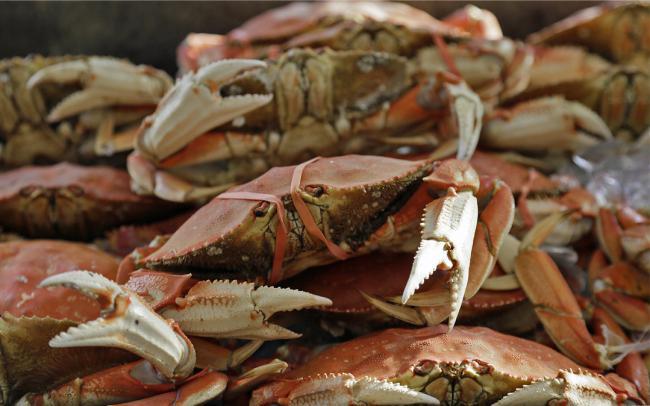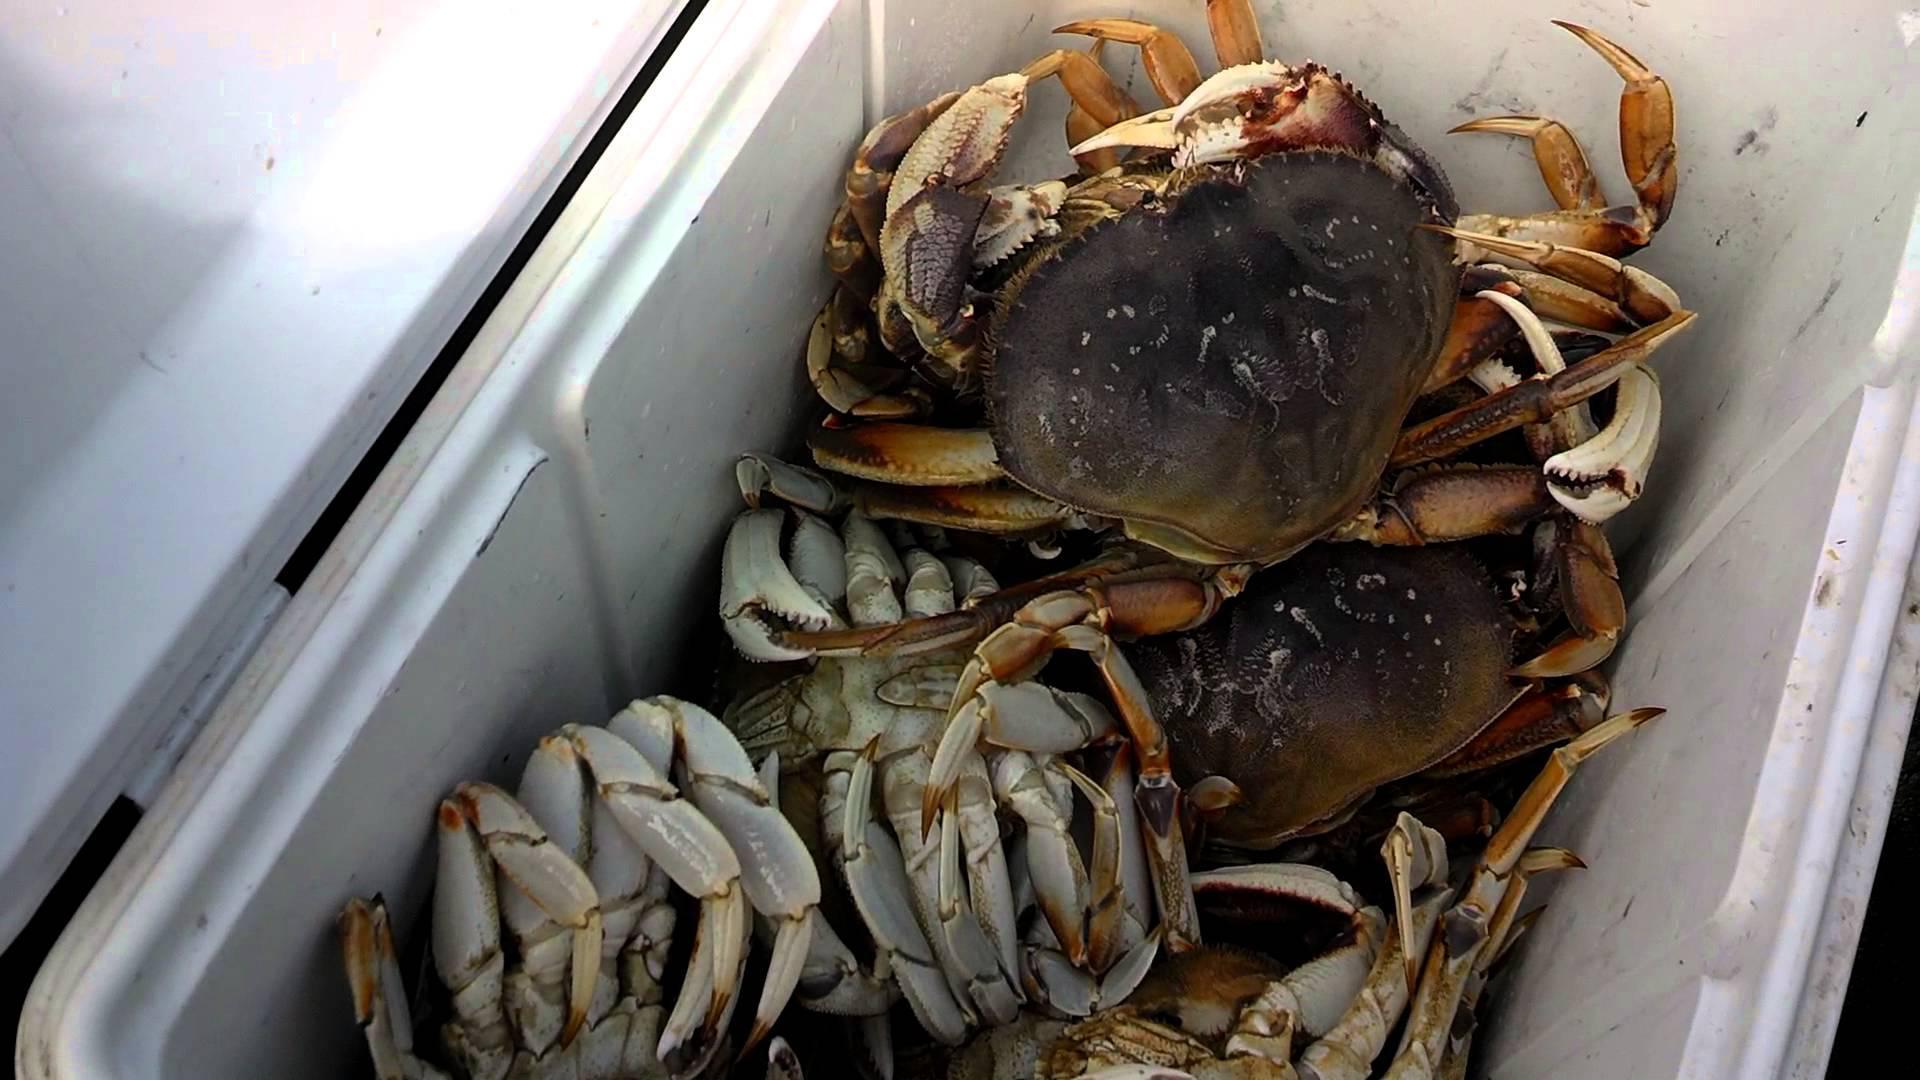The first image is the image on the left, the second image is the image on the right. Examine the images to the left and right. Is the description "The right image shows crabs in a deep container, and the left image shows reddish-orange rightside-up crabs in a pile." accurate? Answer yes or no. Yes. The first image is the image on the left, the second image is the image on the right. Evaluate the accuracy of this statement regarding the images: "The crabs in the left image are mostly brown in color; they are not tinted red.". Is it true? Answer yes or no. No. 